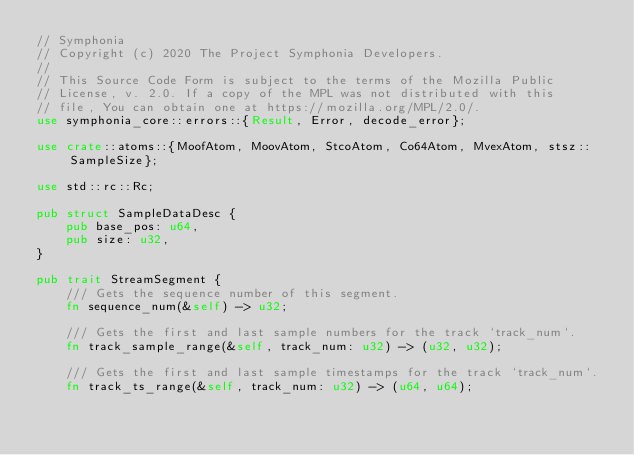<code> <loc_0><loc_0><loc_500><loc_500><_Rust_>// Symphonia
// Copyright (c) 2020 The Project Symphonia Developers.
//
// This Source Code Form is subject to the terms of the Mozilla Public
// License, v. 2.0. If a copy of the MPL was not distributed with this
// file, You can obtain one at https://mozilla.org/MPL/2.0/.
use symphonia_core::errors::{Result, Error, decode_error};

use crate::atoms::{MoofAtom, MoovAtom, StcoAtom, Co64Atom, MvexAtom, stsz::SampleSize};

use std::rc::Rc;

pub struct SampleDataDesc {
    pub base_pos: u64,
    pub size: u32,
}

pub trait StreamSegment {
    /// Gets the sequence number of this segment.
    fn sequence_num(&self) -> u32;

    /// Gets the first and last sample numbers for the track `track_num`.
    fn track_sample_range(&self, track_num: u32) -> (u32, u32);

    /// Gets the first and last sample timestamps for the track `track_num`.
    fn track_ts_range(&self, track_num: u32) -> (u64, u64);
</code> 